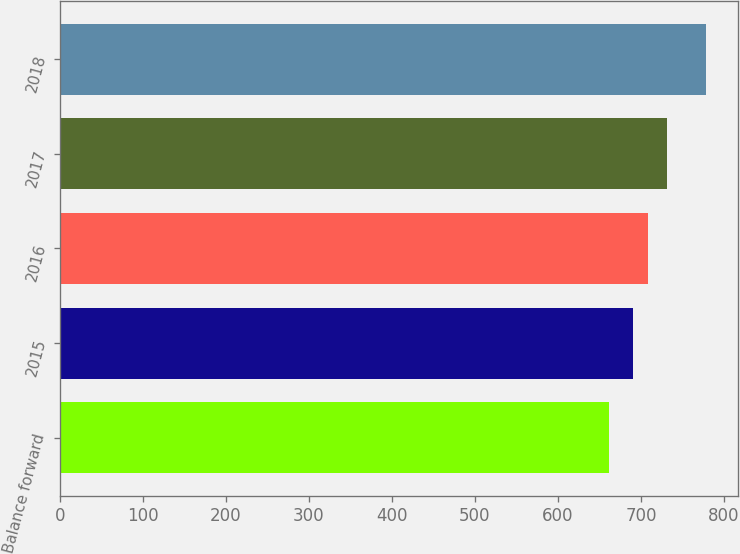Convert chart. <chart><loc_0><loc_0><loc_500><loc_500><bar_chart><fcel>Balance forward<fcel>2015<fcel>2016<fcel>2017<fcel>2018<nl><fcel>661<fcel>690<fcel>709<fcel>731<fcel>778<nl></chart> 